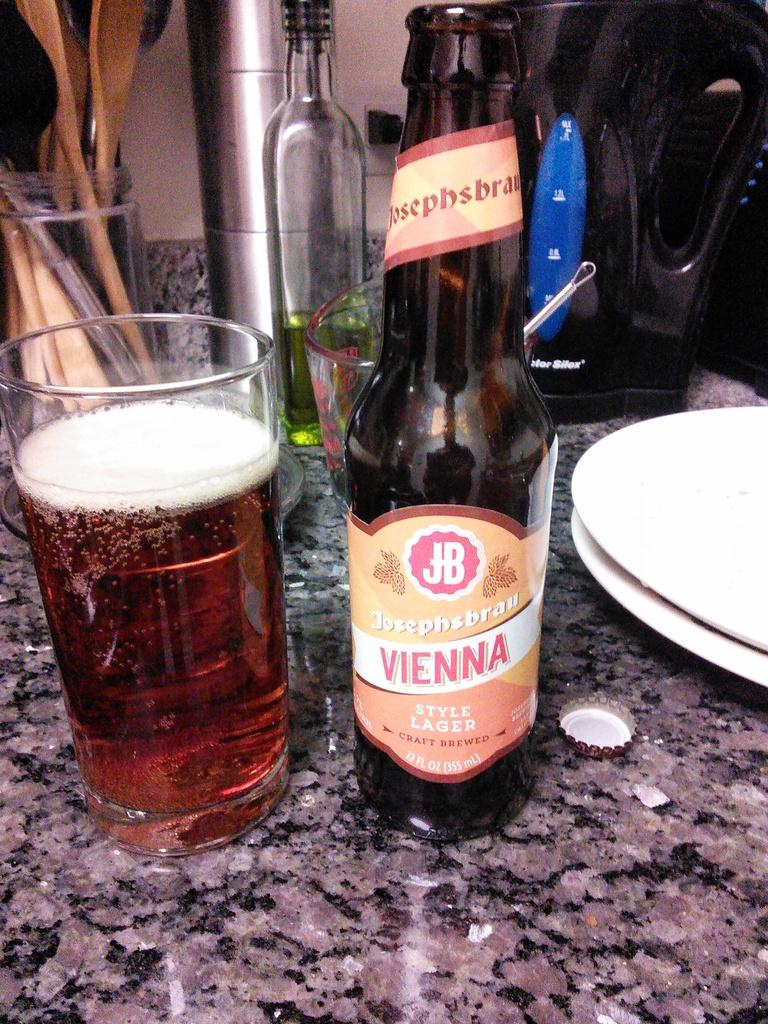What kind of beer is that?
Offer a terse response. Lager. What is the name of the beer?
Ensure brevity in your answer.  Vienna. 